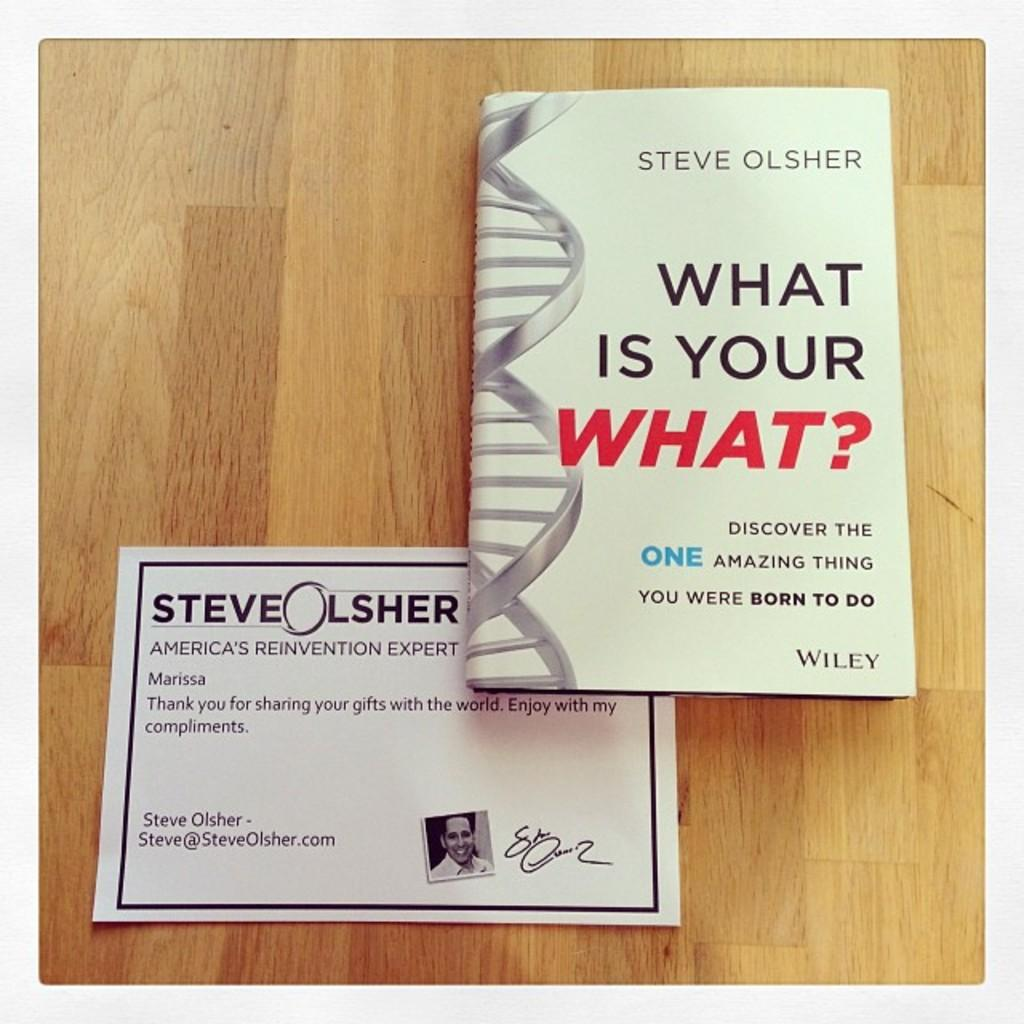<image>
Give a short and clear explanation of the subsequent image. A book called What is your What is on a table by a note. 